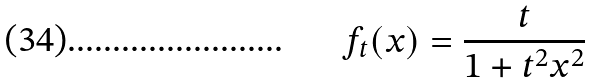<formula> <loc_0><loc_0><loc_500><loc_500>f _ { t } ( x ) = \frac { t } { 1 + t ^ { 2 } x ^ { 2 } }</formula> 